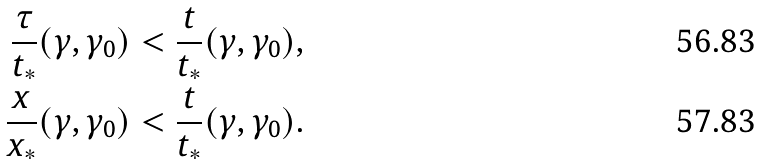<formula> <loc_0><loc_0><loc_500><loc_500>\frac { \tau } { t _ { * } } ( \gamma , \gamma _ { 0 } ) & < \frac { t } { t _ { * } } ( \gamma , \gamma _ { 0 } ) , \\ \frac { x } { x _ { * } } ( \gamma , \gamma _ { 0 } ) & < \frac { t } { t _ { * } } ( \gamma , \gamma _ { 0 } ) .</formula> 